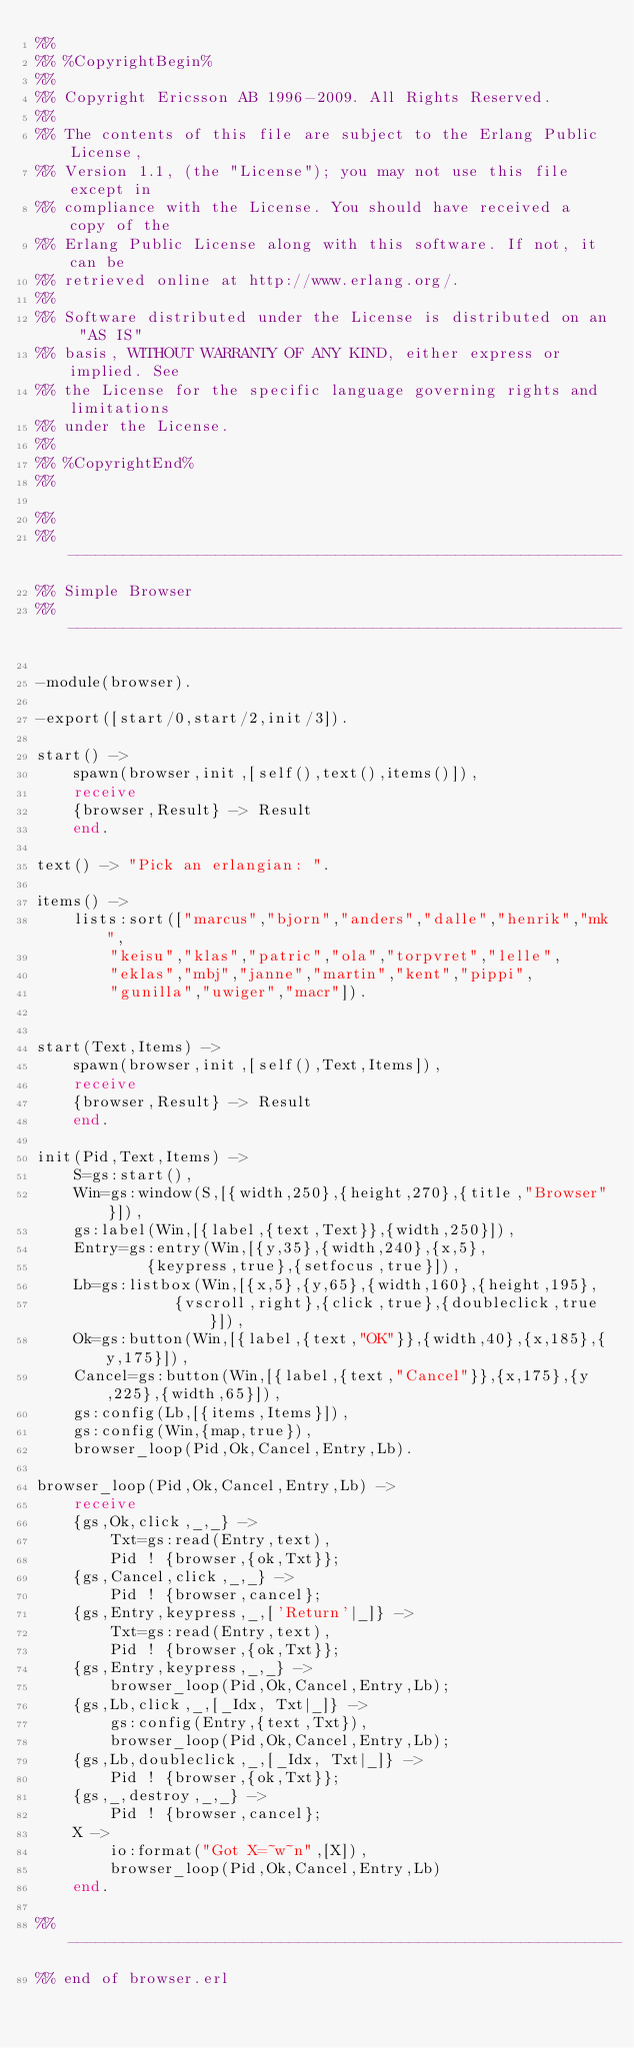Convert code to text. <code><loc_0><loc_0><loc_500><loc_500><_Erlang_>%%
%% %CopyrightBegin%
%% 
%% Copyright Ericsson AB 1996-2009. All Rights Reserved.
%% 
%% The contents of this file are subject to the Erlang Public License,
%% Version 1.1, (the "License"); you may not use this file except in
%% compliance with the License. You should have received a copy of the
%% Erlang Public License along with this software. If not, it can be
%% retrieved online at http://www.erlang.org/.
%% 
%% Software distributed under the License is distributed on an "AS IS"
%% basis, WITHOUT WARRANTY OF ANY KIND, either express or implied. See
%% the License for the specific language governing rights and limitations
%% under the License.
%% 
%% %CopyrightEnd%
%%

%%
%% ------------------------------------------------------------
%% Simple Browser
%% ------------------------------------------------------------

-module(browser).

-export([start/0,start/2,init/3]).

start() ->
    spawn(browser,init,[self(),text(),items()]),	
    receive
	{browser,Result} -> Result
    end.

text() -> "Pick an erlangian: ".

items() ->
    lists:sort(["marcus","bjorn","anders","dalle","henrik","mk",
		"keisu","klas","patric","ola","torpvret","lelle",
		"eklas","mbj","janne","martin","kent","pippi",
		"gunilla","uwiger","macr"]).


start(Text,Items) ->
    spawn(browser,init,[self(),Text,Items]),	
    receive
	{browser,Result} -> Result
    end.

init(Pid,Text,Items) ->
    S=gs:start(),
    Win=gs:window(S,[{width,250},{height,270},{title,"Browser"}]),
    gs:label(Win,[{label,{text,Text}},{width,250}]),
    Entry=gs:entry(Win,[{y,35},{width,240},{x,5},
			{keypress,true},{setfocus,true}]),
    Lb=gs:listbox(Win,[{x,5},{y,65},{width,160},{height,195},
		       {vscroll,right},{click,true},{doubleclick,true}]),
    Ok=gs:button(Win,[{label,{text,"OK"}},{width,40},{x,185},{y,175}]),
    Cancel=gs:button(Win,[{label,{text,"Cancel"}},{x,175},{y,225},{width,65}]),
    gs:config(Lb,[{items,Items}]),
    gs:config(Win,{map,true}),
    browser_loop(Pid,Ok,Cancel,Entry,Lb).

browser_loop(Pid,Ok,Cancel,Entry,Lb) ->
    receive
	{gs,Ok,click,_,_} ->
	    Txt=gs:read(Entry,text),
	    Pid ! {browser,{ok,Txt}};
	{gs,Cancel,click,_,_} ->
	    Pid ! {browser,cancel};
	{gs,Entry,keypress,_,['Return'|_]} ->
	    Txt=gs:read(Entry,text),
	    Pid ! {browser,{ok,Txt}};
	{gs,Entry,keypress,_,_} ->
	    browser_loop(Pid,Ok,Cancel,Entry,Lb);
	{gs,Lb,click,_,[_Idx, Txt|_]} ->
	    gs:config(Entry,{text,Txt}),
	    browser_loop(Pid,Ok,Cancel,Entry,Lb);
	{gs,Lb,doubleclick,_,[_Idx, Txt|_]} ->
	    Pid ! {browser,{ok,Txt}};
	{gs,_,destroy,_,_} ->
	    Pid ! {browser,cancel};
	X ->
	    io:format("Got X=~w~n",[X]),
	    browser_loop(Pid,Ok,Cancel,Entry,Lb)
    end.

%% ------------------------------------------------------------
%% end of browser.erl
</code> 